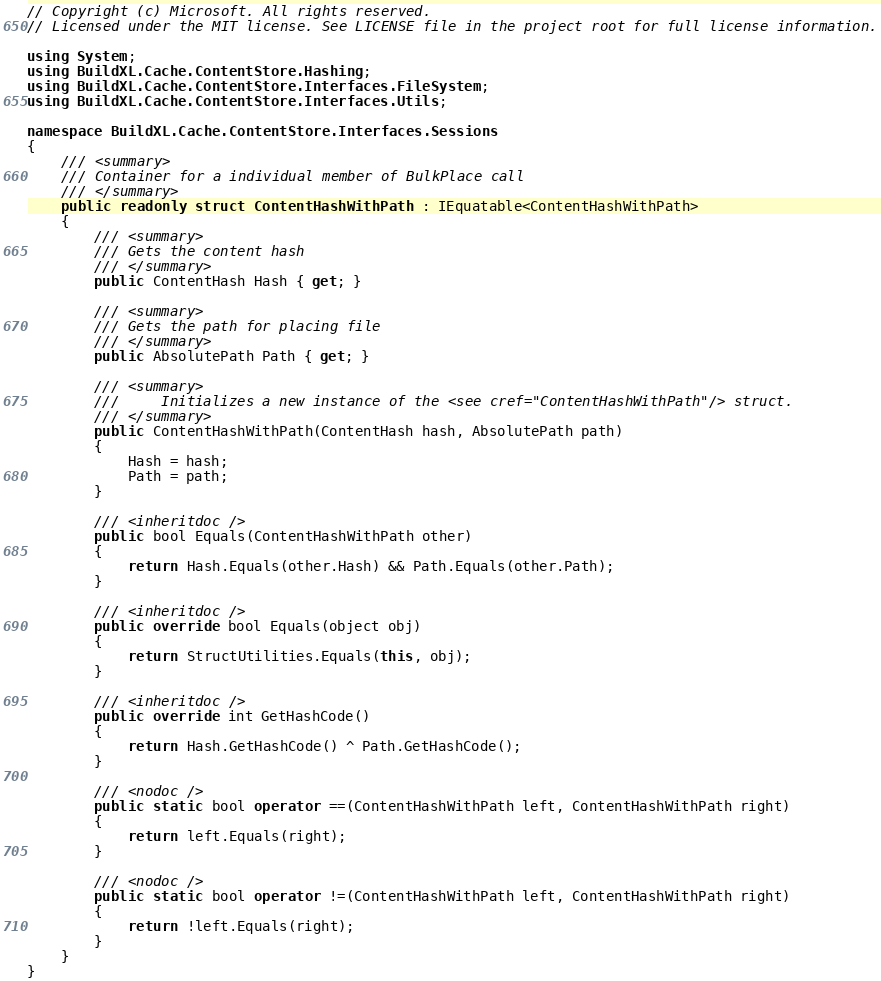Convert code to text. <code><loc_0><loc_0><loc_500><loc_500><_C#_>// Copyright (c) Microsoft. All rights reserved.
// Licensed under the MIT license. See LICENSE file in the project root for full license information.

using System;
using BuildXL.Cache.ContentStore.Hashing;
using BuildXL.Cache.ContentStore.Interfaces.FileSystem;
using BuildXL.Cache.ContentStore.Interfaces.Utils;

namespace BuildXL.Cache.ContentStore.Interfaces.Sessions
{
    /// <summary>
    /// Container for a individual member of BulkPlace call
    /// </summary>
    public readonly struct ContentHashWithPath : IEquatable<ContentHashWithPath>
    {
        /// <summary>
        /// Gets the content hash
        /// </summary>
        public ContentHash Hash { get; }

        /// <summary>
        /// Gets the path for placing file
        /// </summary>
        public AbsolutePath Path { get; }

        /// <summary>
        ///     Initializes a new instance of the <see cref="ContentHashWithPath"/> struct.
        /// </summary>
        public ContentHashWithPath(ContentHash hash, AbsolutePath path)
        {
            Hash = hash;
            Path = path;
        }

        /// <inheritdoc />
        public bool Equals(ContentHashWithPath other)
        {
            return Hash.Equals(other.Hash) && Path.Equals(other.Path);
        }

        /// <inheritdoc />
        public override bool Equals(object obj)
        {
            return StructUtilities.Equals(this, obj);
        }

        /// <inheritdoc />
        public override int GetHashCode()
        {
            return Hash.GetHashCode() ^ Path.GetHashCode();
        }

        /// <nodoc />
        public static bool operator ==(ContentHashWithPath left, ContentHashWithPath right)
        {
            return left.Equals(right);
        }

        /// <nodoc />
        public static bool operator !=(ContentHashWithPath left, ContentHashWithPath right)
        {
            return !left.Equals(right);
        }
    }
}
</code> 